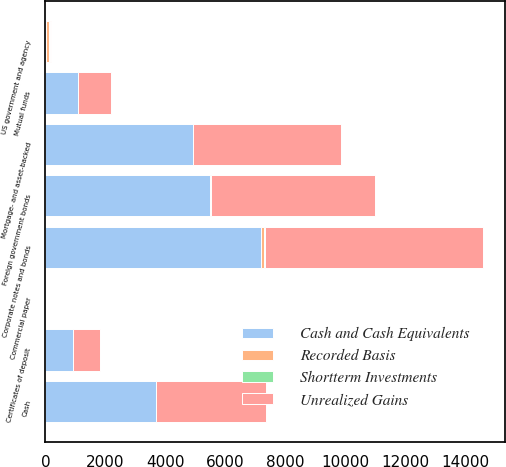Convert chart. <chart><loc_0><loc_0><loc_500><loc_500><stacked_bar_chart><ecel><fcel>Cash<fcel>Mutual funds<fcel>Commercial paper<fcel>Certificates of deposit<fcel>US government and agency<fcel>Foreign government bonds<fcel>Mortgage- and asset-backed<fcel>Corporate notes and bonds<nl><fcel>Cash and Cash Equivalents<fcel>3679<fcel>1100<fcel>1<fcel>906<fcel>33.5<fcel>5477<fcel>4899<fcel>7192<nl><fcel>Recorded Basis<fcel>0<fcel>0<fcel>0<fcel>0<fcel>76<fcel>3<fcel>23<fcel>97<nl><fcel>Shortterm Investments<fcel>0<fcel>0<fcel>0<fcel>0<fcel>30<fcel>24<fcel>6<fcel>37<nl><fcel>Unrealized Gains<fcel>3679<fcel>1100<fcel>1<fcel>906<fcel>33.5<fcel>5456<fcel>4916<fcel>7252<nl></chart> 